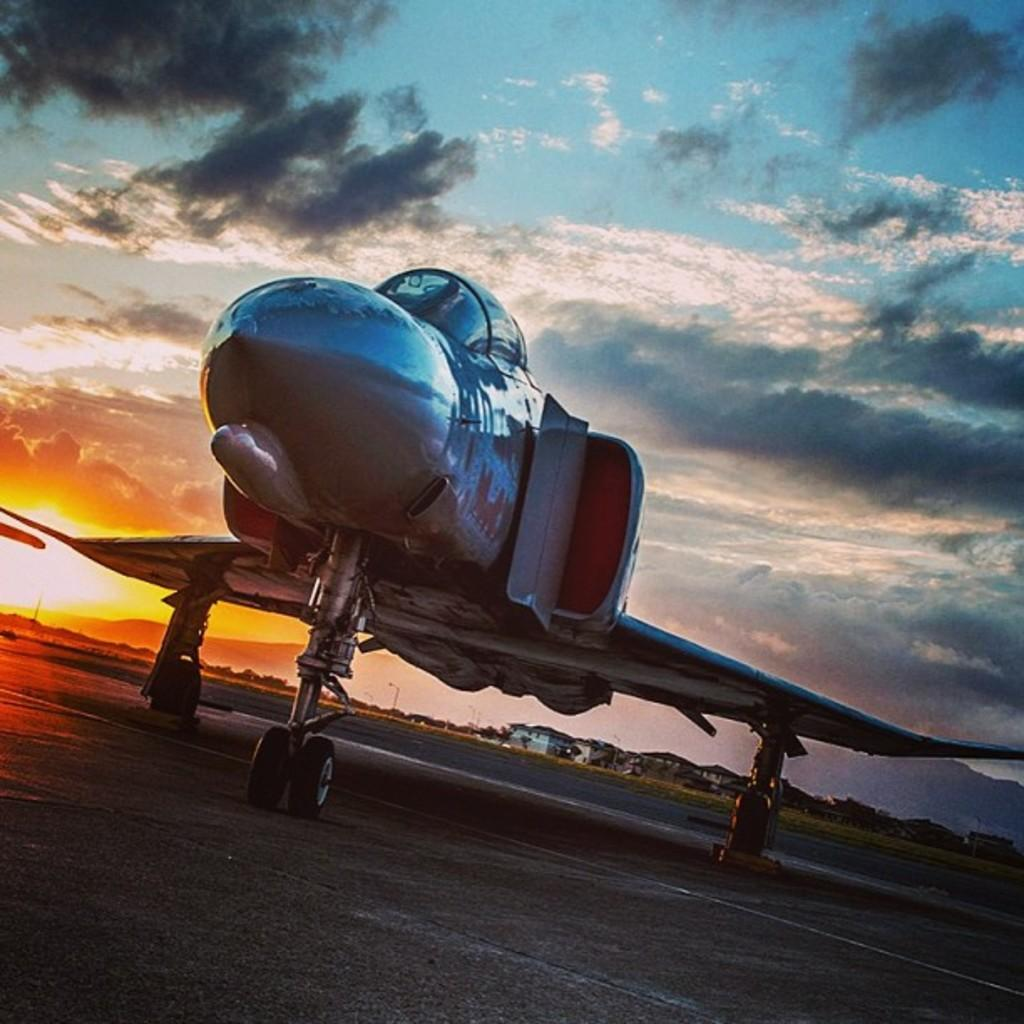What is the main subject of the picture? The main subject of the picture is a plane. Where is the plane located in the image? The plane is parked on a path in the image. What can be seen in the distance in the image? Houses, trees, and poles with lights are visible in the distance. What is visible in the sky in the image? The sky is visible in the image, with clouds and the sun present. What type of ornament is hanging from the plane's wing in the image? There is no ornament hanging from the plane's wing in the image. Do you believe the plane is capable of flying in the image? The image does not provide any information about the plane's ability to fly, but it is parked on a path, which suggests it is not currently in flight. 